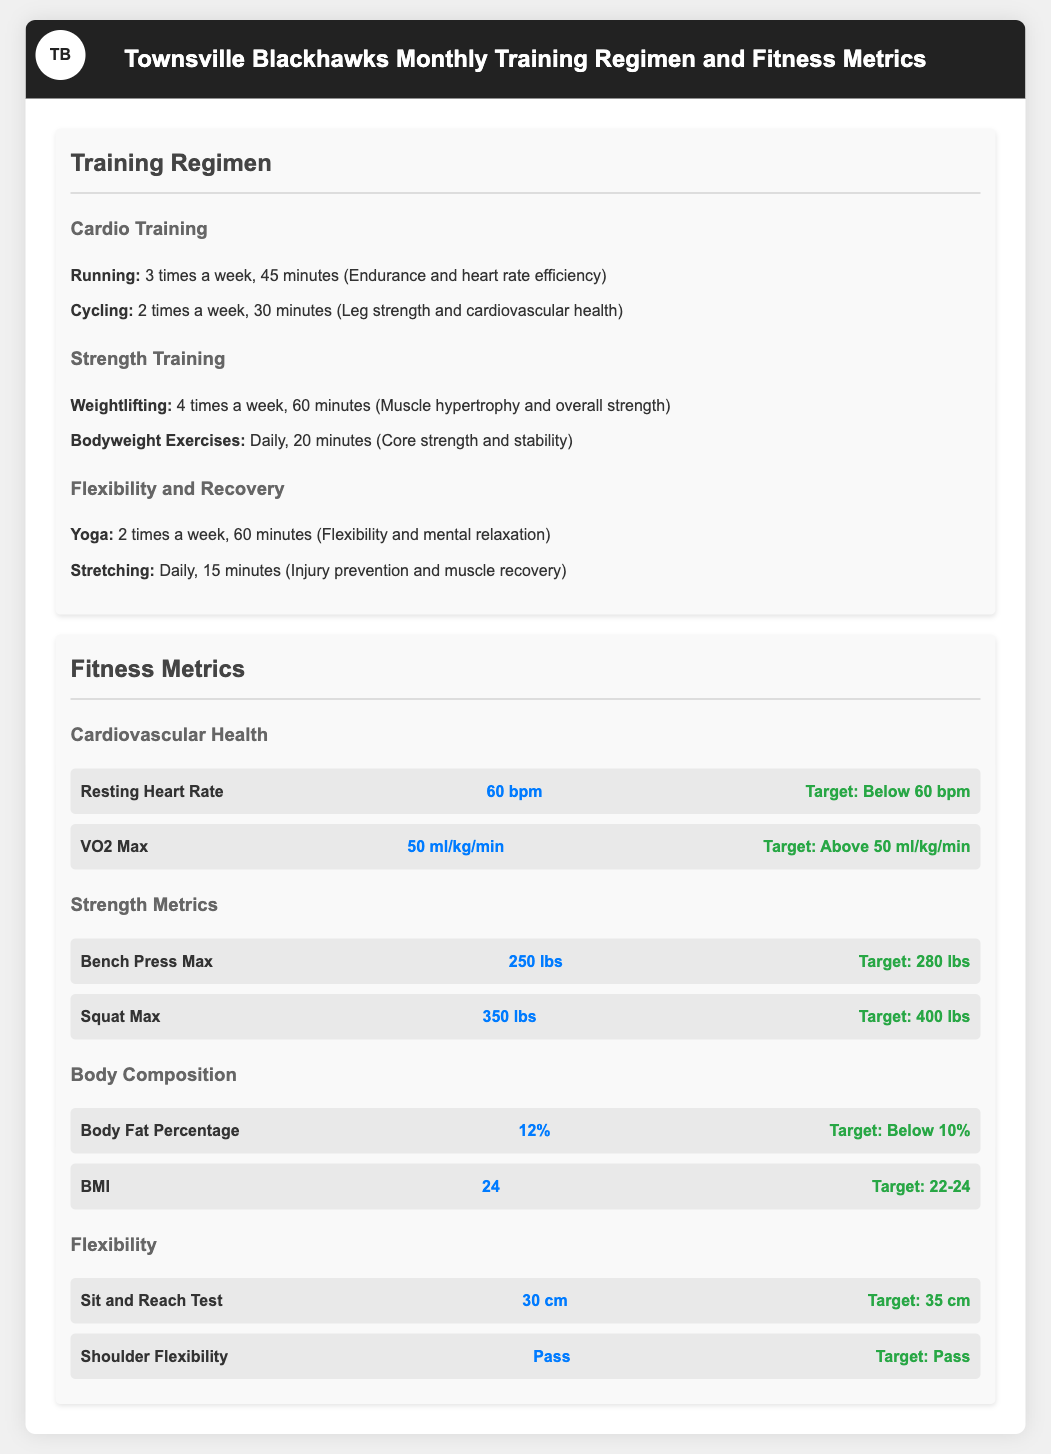What is the maximum weight for the bench press? The maximum weight for the bench press metric in the document is directly provided.
Answer: 250 lbs How many times a week are players required to run? The training regimen specifies the frequency of running sessions in the cardio training section.
Answer: 3 times a week What is the target for body fat percentage? The document lists the target for body fat percentage under the body composition section.
Answer: Below 10% What is the VO2 Max value? The VO2 Max value is cited under the cardiovascular health metrics in the document.
Answer: 50 ml/kg/min How long is the daily stretching routine? The duration of the daily stretching routine is mentioned in the flexibility and recovery segment of the document.
Answer: 15 minutes What is the target for the squat max? The target for squat max is provided in the strength metrics section of the document.
Answer: 400 lbs How many times a week is yoga practiced? The document specifies the frequency of yoga sessions in the flexibility and recovery training section.
Answer: 2 times a week What score did the players achieve in the sit and reach test? The result for the sit and reach test is provided under flexibility metrics in the fitness section of the document.
Answer: 30 cm What is the target range for BMI? The target range for BMI is explicitly stated under body composition metrics in the document.
Answer: 22-24 